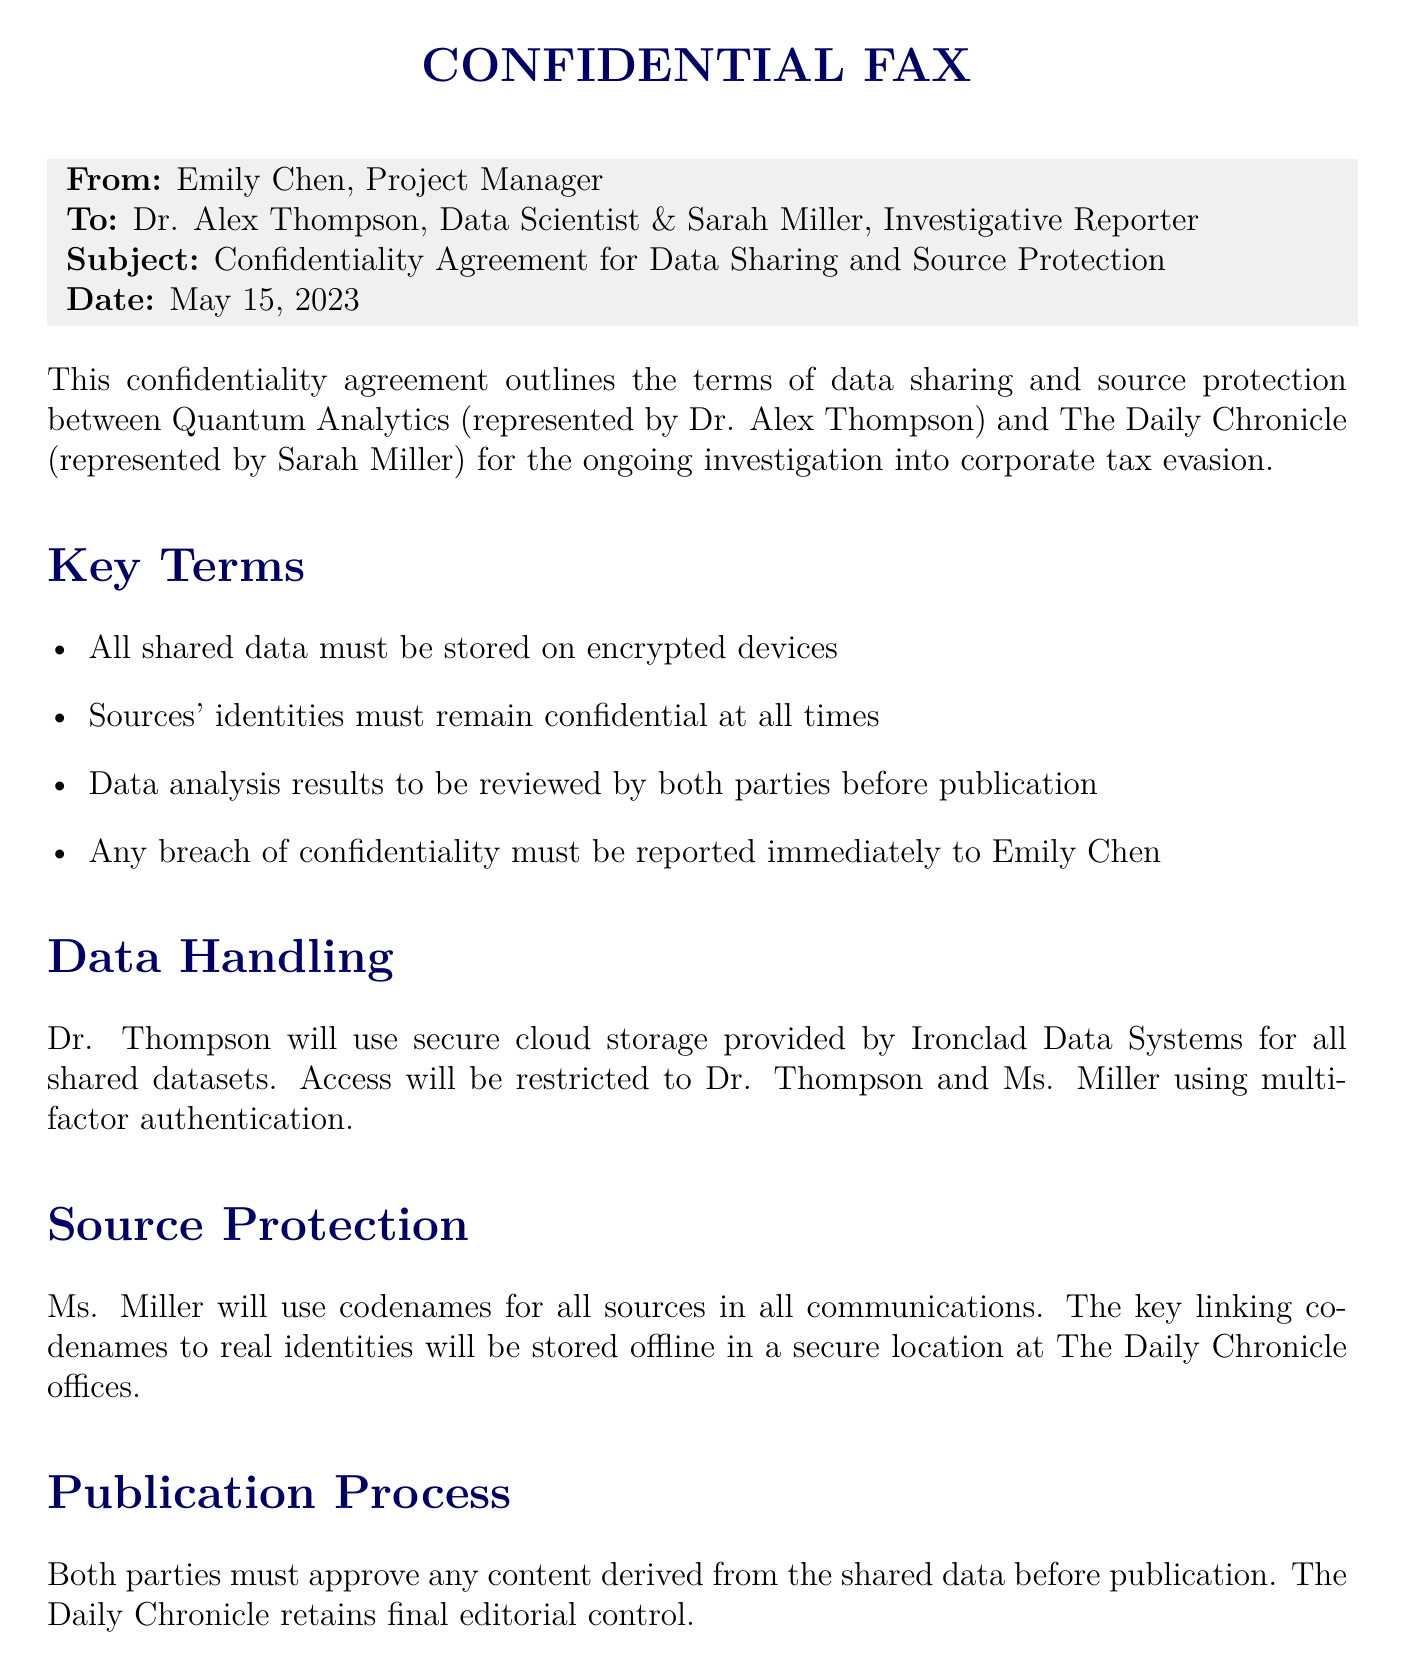What is the subject of the fax? The subject is specified in the header section, indicating the main focus of the fax.
Answer: Confidentiality Agreement for Data Sharing and Source Protection Who is the sender of the fax? The sender's name is noted prominently in the 'From' section of the fax.
Answer: Emily Chen What date was the fax sent? The date is clearly mentioned in the header section of the document.
Answer: May 15, 2023 What is the name of the data scientist mentioned? The document explicitly identifies the data scientist involved in the agreement.
Answer: Dr. Alex Thompson What document storage method is mentioned in the agreement? The document specifies a secure storage method for the shared data.
Answer: Encrypted devices How long will the confidentiality agreement remain in effect? The duration of the agreement is stated in a specific section of the document.
Answer: Two years following the publication What type of authentication will be used for access? The security method for accessing shared data is outlined in the document.
Answer: Multi-factor authentication Who retains final editorial control over the publication? The document explicitly states who has the final say in editorial decisions.
Answer: The Daily Chronicle What must be done in case of a confidentiality breach? The procedure to follow in case of a breach is stated in the key terms section.
Answer: Report immediately to Emily Chen 